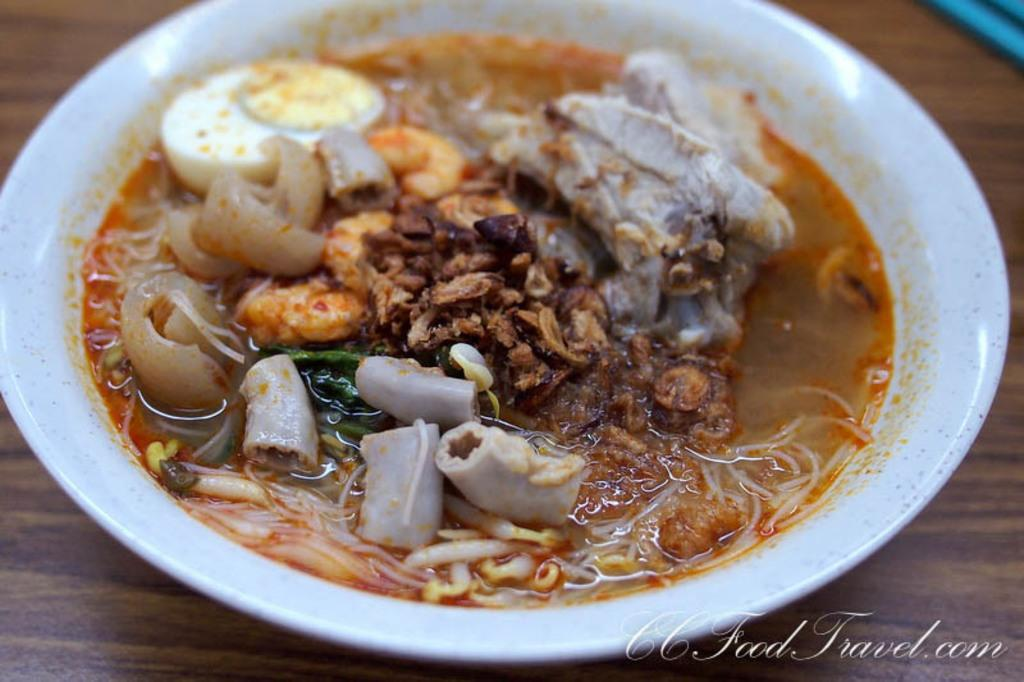What is in the bowl that is visible in the image? There is a food item in a bowl in the image. Where is the bowl located in the image? The bowl is placed on a table in the image. What can be seen at the bottom of the image? There is some text at the bottom of the image. What type of linen is draped over the food item in the image? There is no linen present in the image; the food item is in a bowl on a table. How many birds are perched on the edge of the bowl in the image? There are no birds present in the image; it only features a food item in a bowl on a table with some text at the bottom. 